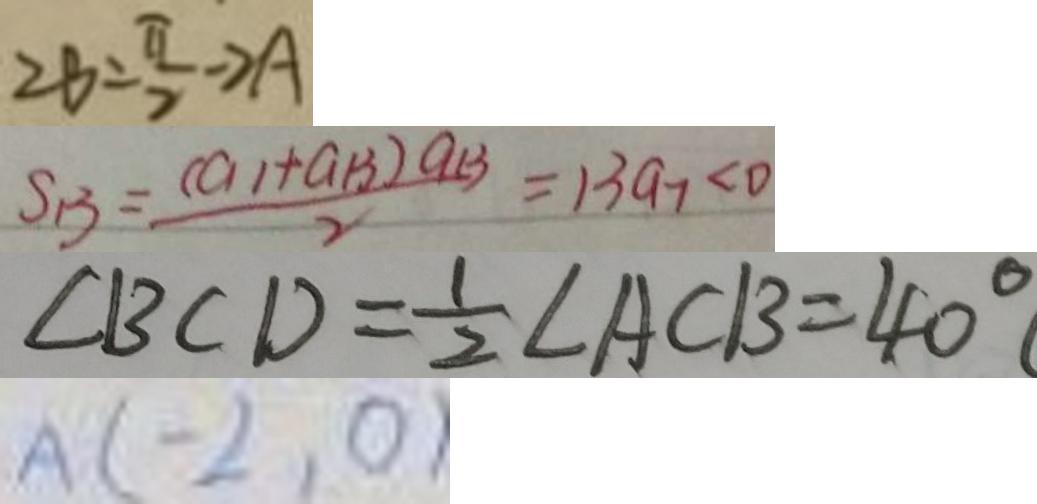Convert formula to latex. <formula><loc_0><loc_0><loc_500><loc_500>2 B = \frac { \pi } { 2 } - 2 A 
 S _ { B } = \frac { ( a _ { 1 } + G _ { 1 } 3 ) a _ { 1 3 } } { 2 } = 1 3 a _ { 7 } < 0 
 \angle B C D = \frac { 1 } { 2 } \angle A C B = 4 0 ^ { \circ } 
 A ( - 2 , 0</formula> 